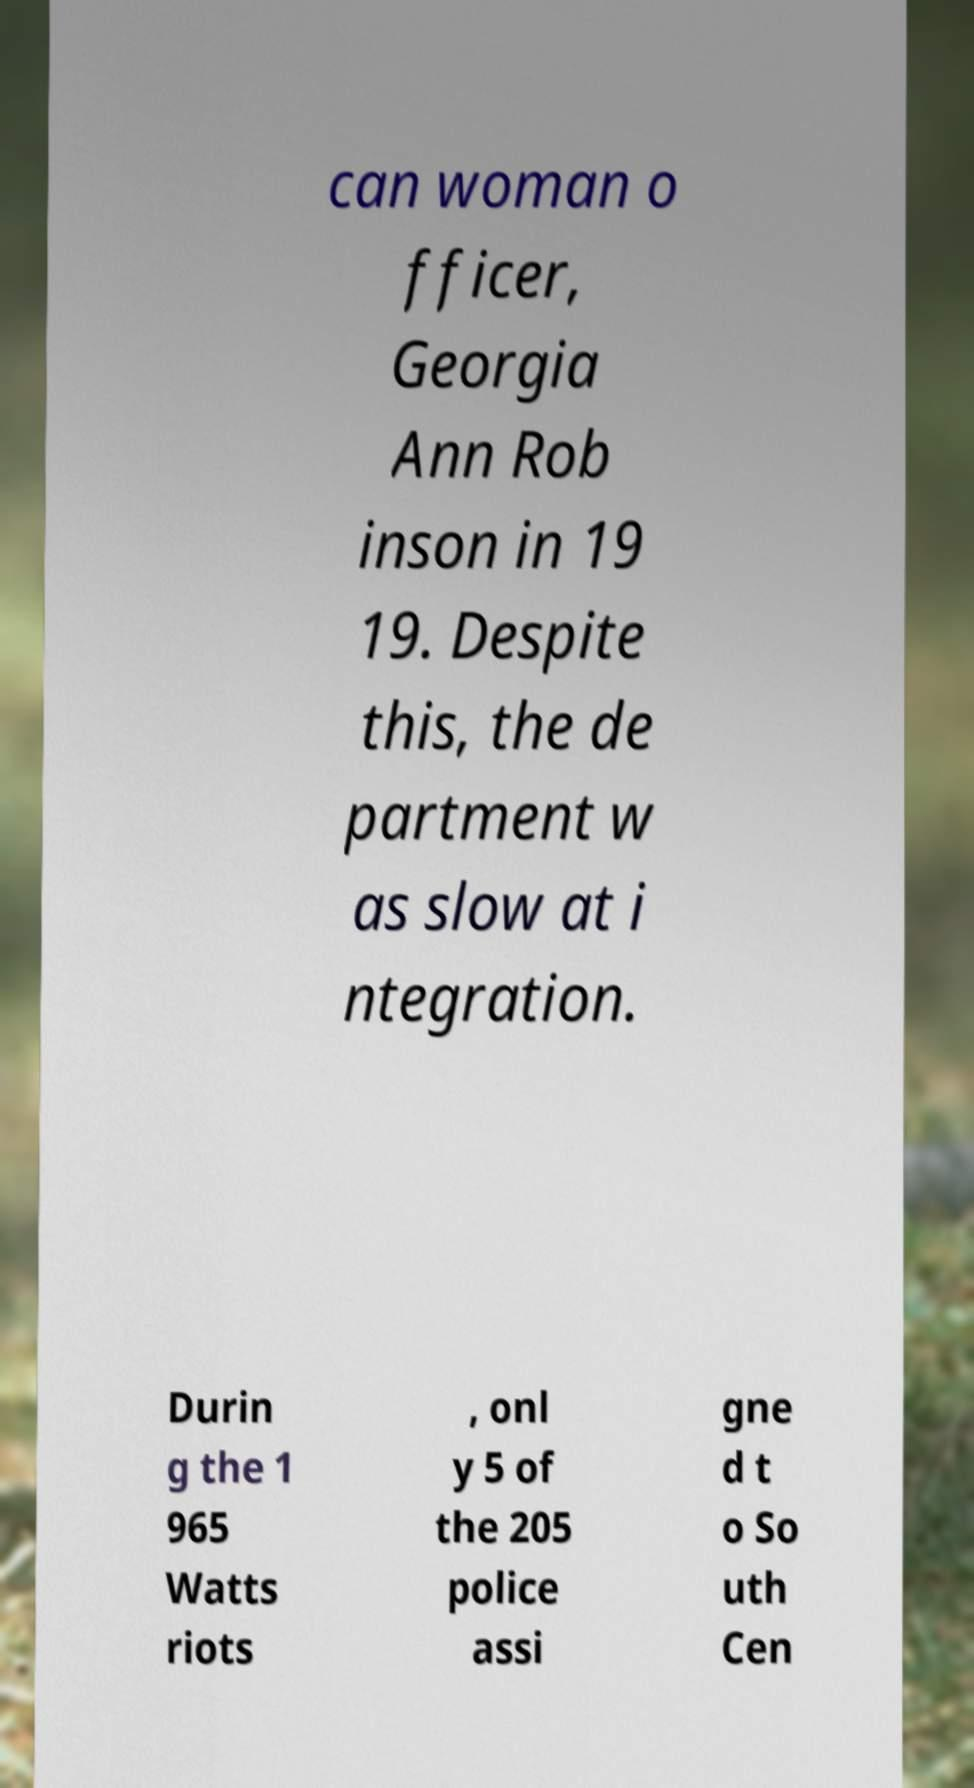Please identify and transcribe the text found in this image. can woman o fficer, Georgia Ann Rob inson in 19 19. Despite this, the de partment w as slow at i ntegration. Durin g the 1 965 Watts riots , onl y 5 of the 205 police assi gne d t o So uth Cen 